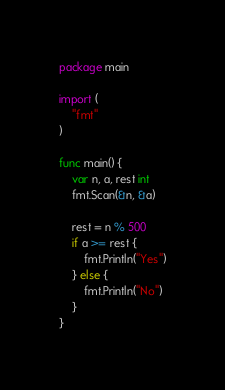Convert code to text. <code><loc_0><loc_0><loc_500><loc_500><_Go_>package main

import (
	"fmt"
)

func main() {
	var n, a, rest int
	fmt.Scan(&n, &a)
	
	rest = n % 500
	if a >= rest {
		fmt.Println("Yes")
	} else {
		fmt.Println("No")
	}
}</code> 